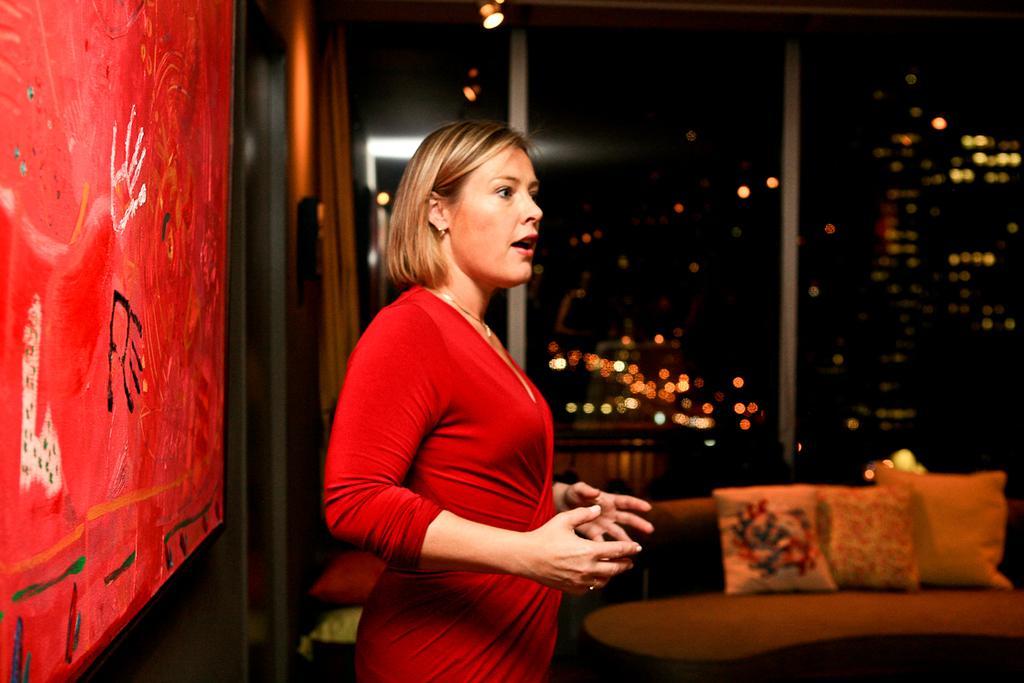Please provide a concise description of this image. In the picture we can see a side view of a woman standing and explaining something and she is with a red dress and behind her we can see a red color curtain with some hand prints to it and beside her we can see a sofa with some pillows and beside it we can see a glass window and from it we can see buildings and lights. 